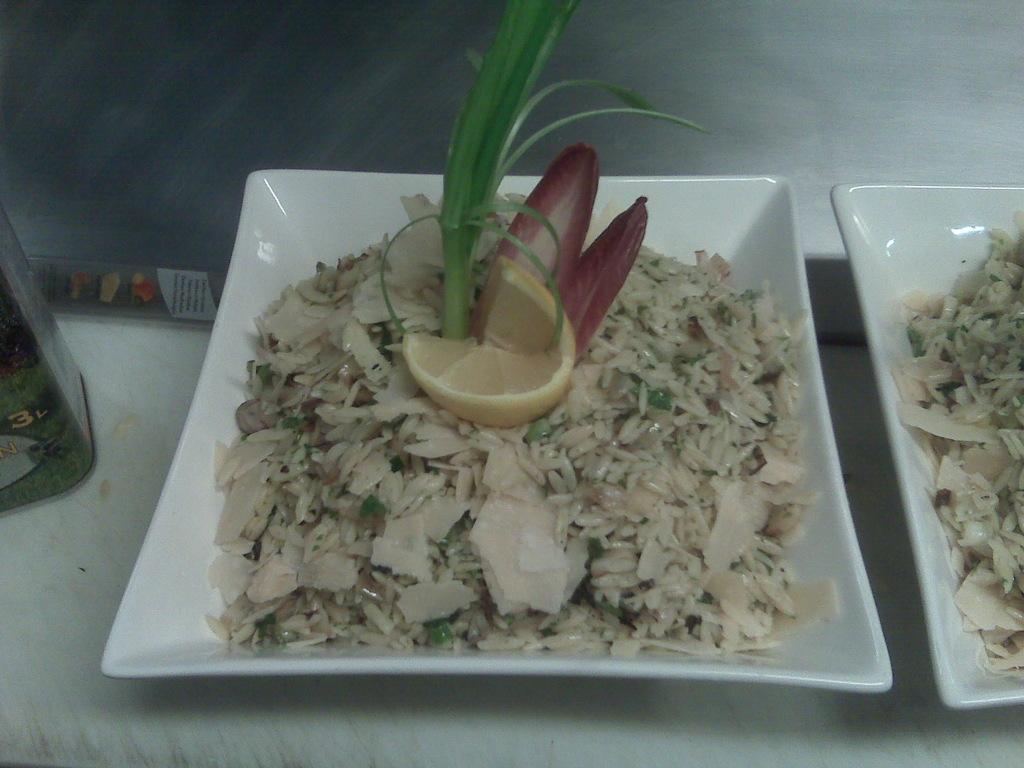Describe this image in one or two sentences. In this picture there is a plate in the center of the image, which contains rice and other food items in it and there is another plate on the right side of the image. 